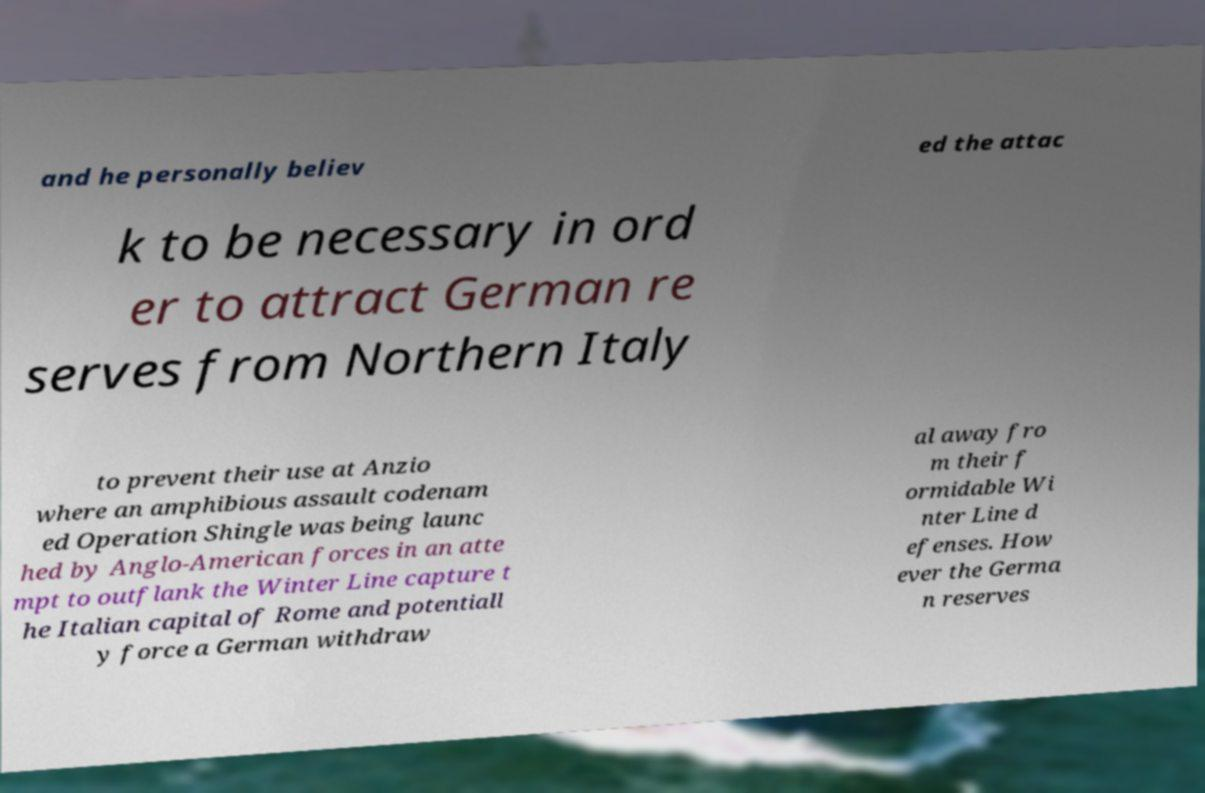Please identify and transcribe the text found in this image. and he personally believ ed the attac k to be necessary in ord er to attract German re serves from Northern Italy to prevent their use at Anzio where an amphibious assault codenam ed Operation Shingle was being launc hed by Anglo-American forces in an atte mpt to outflank the Winter Line capture t he Italian capital of Rome and potentiall y force a German withdraw al away fro m their f ormidable Wi nter Line d efenses. How ever the Germa n reserves 